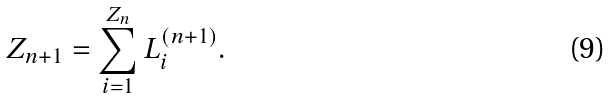Convert formula to latex. <formula><loc_0><loc_0><loc_500><loc_500>Z _ { n + 1 } = \sum _ { i = 1 } ^ { Z _ { n } } L _ { i } ^ { ( n + 1 ) } .</formula> 